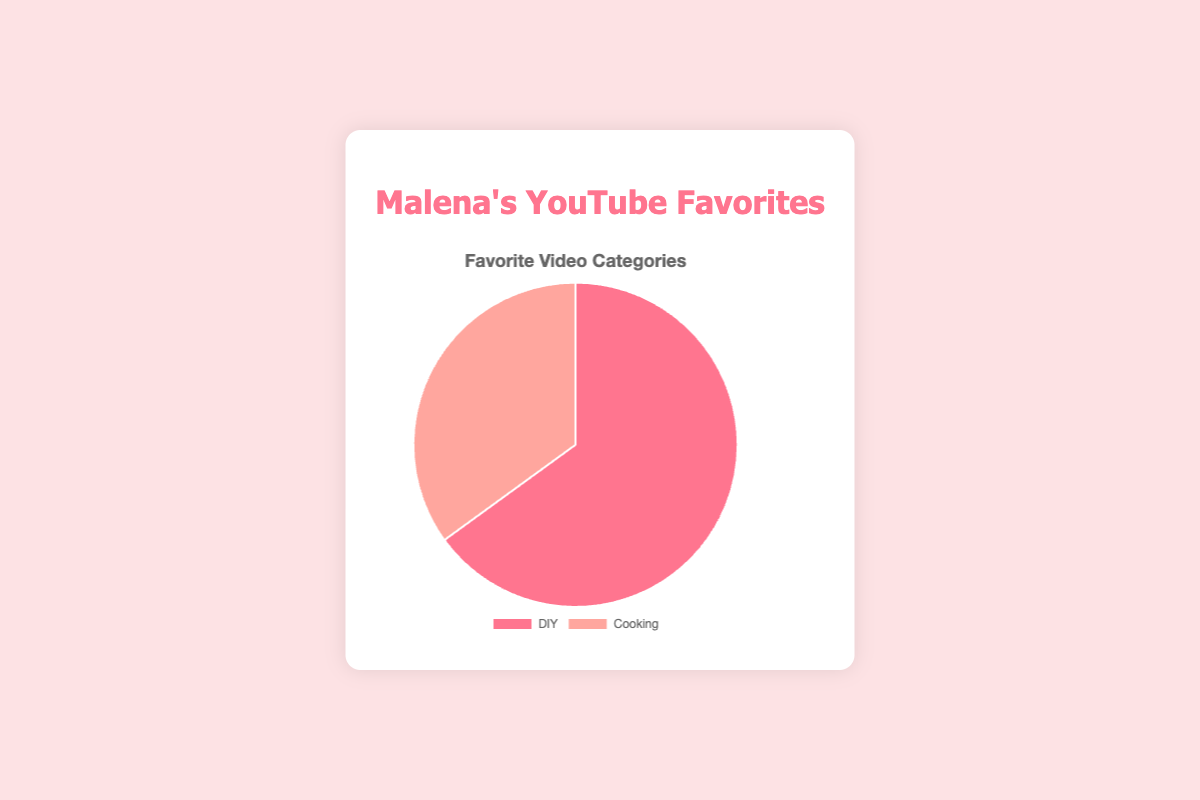What percentage of people prefer DIY videos? The figure shows that the percentage of people who prefer DIY videos is highlighted in the pie chart. The segment labeled "DIY" has a percentage value next to it.
Answer: 65% Which video category has a higher preference among viewers? To determine which category has a higher preference, compare the percentages of the categories shown in the pie chart. The segment with the higher percentage represents the more preferred category. The DIY segment is 65%, and the Cooking segment is 35%, so DIY is higher.
Answer: DIY What is the difference in preference between DIY and Cooking videos? Subtract the percentage of Cooking from the percentage of DIY. DIY has 65%, and Cooking has 35%. So, 65% - 35% = 30%.
Answer: 30% If you combine both categories, what is the total percentage represented in the pie chart? Add the percentages of both categories shown in the pie chart. DIY is 65%, and Cooking is 35%. So, 65% + 35% = 100%.
Answer: 100% What color represents the Cooking video category in the pie chart? Look at the visual attributes of the pie chart. Each section is color-coded. The segment labeled "Cooking" is colored.
Answer: Light orange Which segment of the pie chart is larger in area, and by how much in percentage points? Compare the two segments by their size. The DIY segment is larger than the Cooking segment. The difference is found by subtracting the percentage of Cooking from the percentage of DIY: 65% - 35% = 30%.
Answer: DIY by 30 percentage points What percentage of viewers prefer Cooking videos? The figure shows that the percentage of people who prefer Cooking videos is highlighted in the pie chart. The segment labeled "Cooking" has a percentage value next to it.
Answer: 35% If you were to describe the main insight from this pie chart, what would it be? The pie chart shows the distribution of favorite video categories among viewers of Malena's YouTube channel. The main insight is that a majority of the viewers prefer DIY videos (65%), while a smaller portion prefers Cooking videos (35%).
Answer: Majority prefer DIY If the total number of viewers is 200, how many viewers prefer Cooking videos? Use the percentage from the pie chart for Cooking (35%) and multiply it by the total number of viewers. 35% of 200 is calculated as (35/100) * 200 = 70.
Answer: 70 viewers By what factor is the preference for DIY videos greater than for Cooking videos? Divide the percentage of DIY by the percentage of Cooking: 65% / 35% = 1.857.
Answer: 1.857 